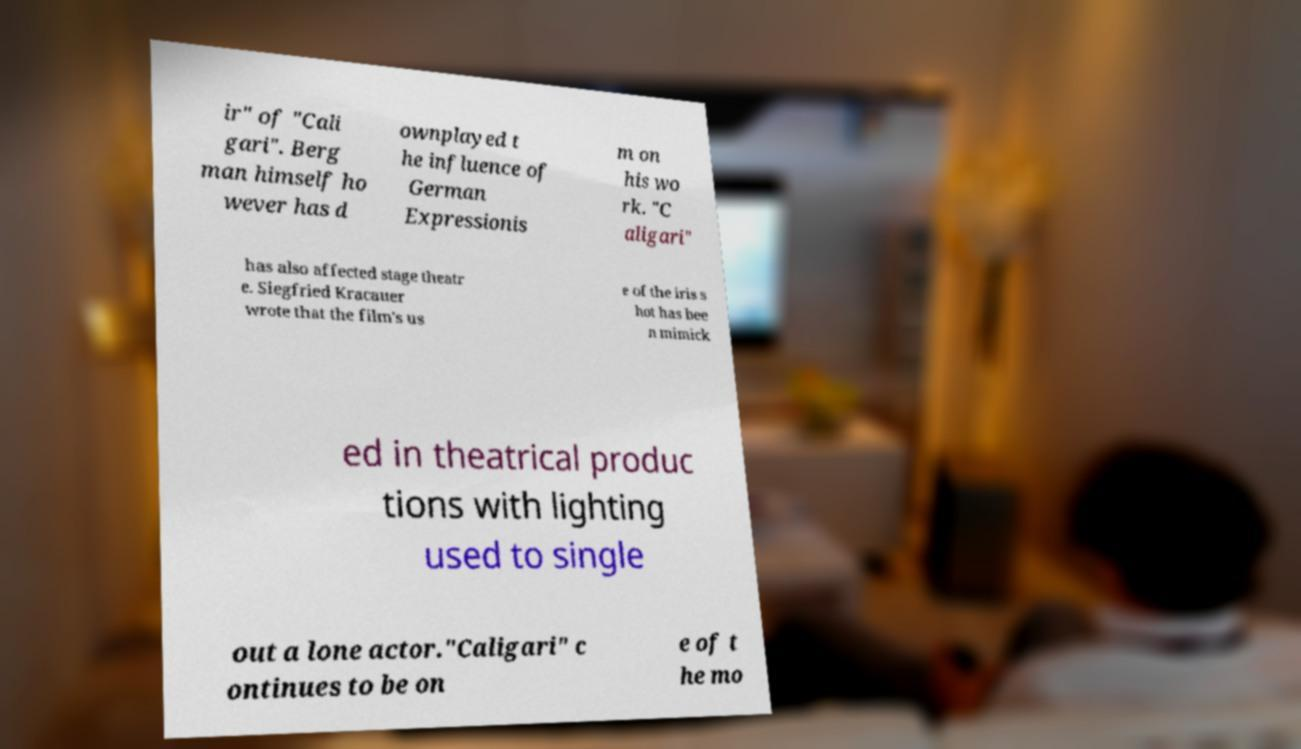For documentation purposes, I need the text within this image transcribed. Could you provide that? ir" of "Cali gari". Berg man himself ho wever has d ownplayed t he influence of German Expressionis m on his wo rk. "C aligari" has also affected stage theatr e. Siegfried Kracauer wrote that the film's us e of the iris s hot has bee n mimick ed in theatrical produc tions with lighting used to single out a lone actor."Caligari" c ontinues to be on e of t he mo 